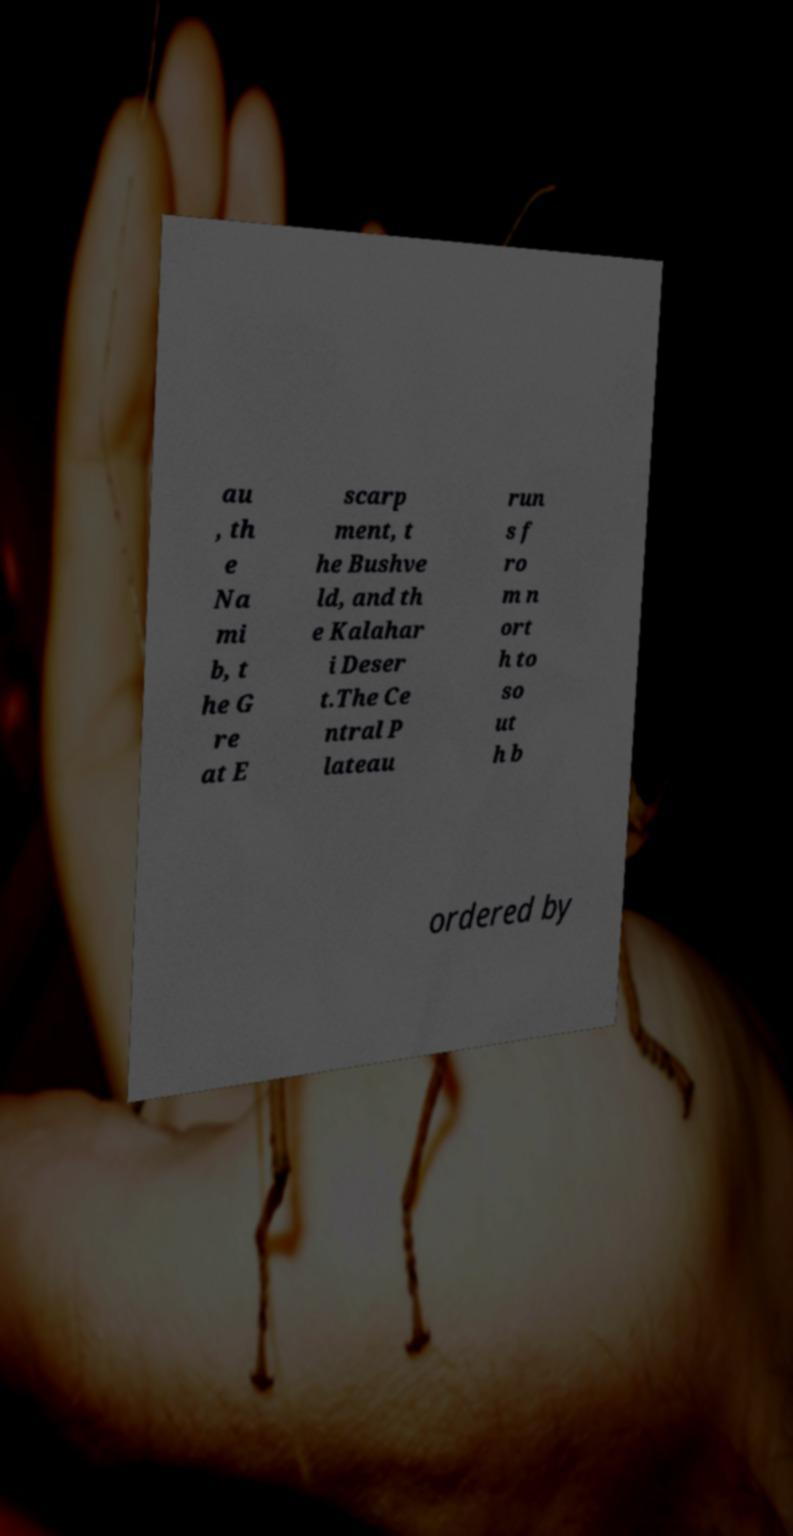For documentation purposes, I need the text within this image transcribed. Could you provide that? au , th e Na mi b, t he G re at E scarp ment, t he Bushve ld, and th e Kalahar i Deser t.The Ce ntral P lateau run s f ro m n ort h to so ut h b ordered by 